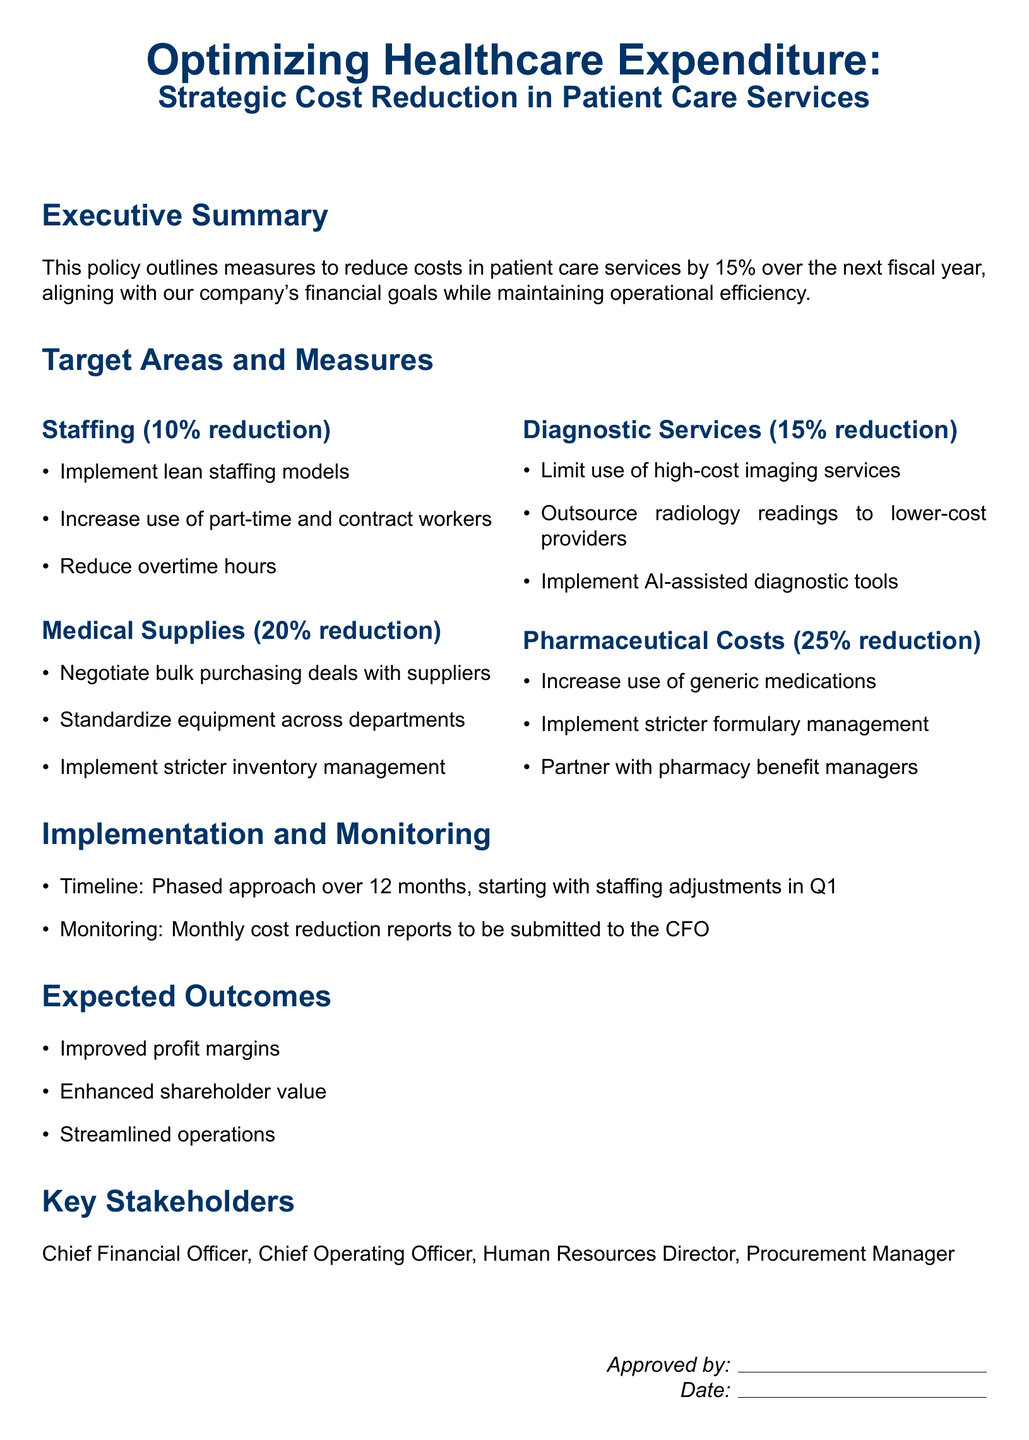What is the target cost reduction percentage for patient care services? The target cost reduction percentage mentioned in the document is to reduce costs by 15%.
Answer: 15% What is the first area targeted for cost reduction? The first area mentioned in the document for cost reduction is staffing.
Answer: Staffing What is the expected reduction percentage for pharmaceutical costs? The expected reduction percentage for pharmaceutical costs is 25%.
Answer: 25% How often will cost reduction reports be submitted? The document states that cost reduction reports will be submitted monthly.
Answer: Monthly Who is responsible for monitoring the cost reduction implementation? The Chief Financial Officer (CFO) is responsible for monitoring the implementation as mentioned in the document.
Answer: Chief Financial Officer Which diagnostic service has a 15% reduction target? The document specifies that diagnostic services have a 15% reduction target.
Answer: Diagnostic Services What is one strategy to reduce medical supplies costs? One strategy to reduce medical supplies costs is to negotiate bulk purchasing deals with suppliers.
Answer: Negotiate bulk purchasing deals What is the timeline for implementing the cost reduction measures? The timeline for implementing the cost reduction measures is over 12 months.
Answer: 12 months What type of report will be provided to the CFO? The report provided to the CFO will be a monthly cost reduction report.
Answer: Monthly cost reduction report 